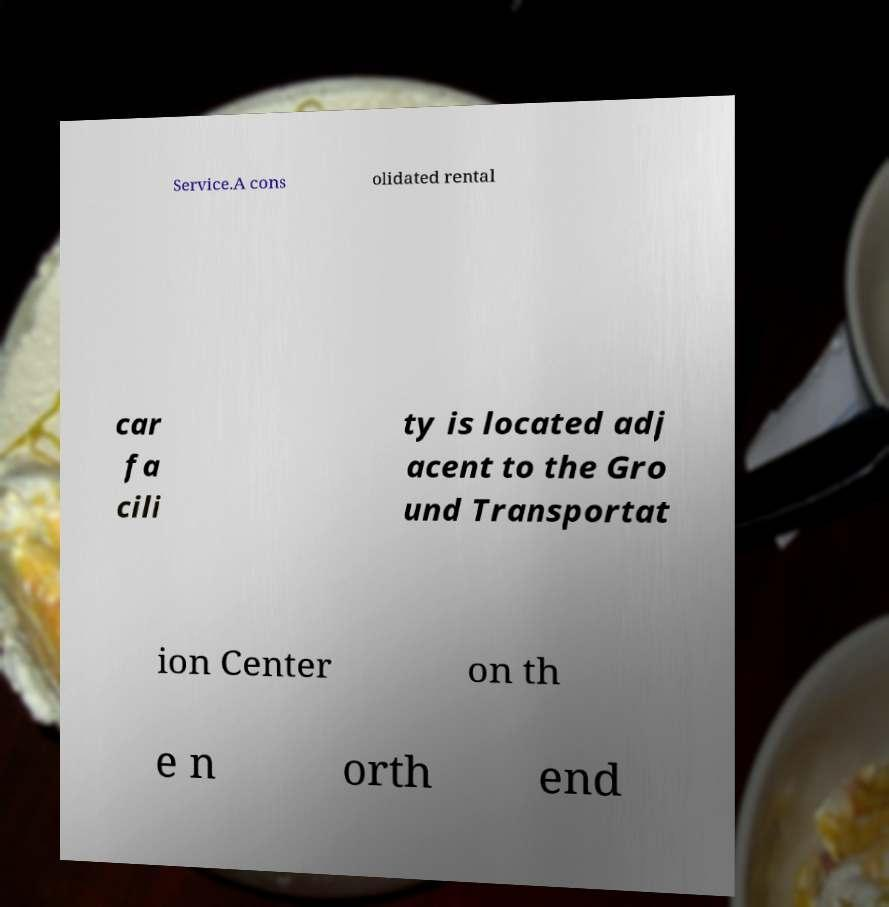Can you accurately transcribe the text from the provided image for me? Service.A cons olidated rental car fa cili ty is located adj acent to the Gro und Transportat ion Center on th e n orth end 